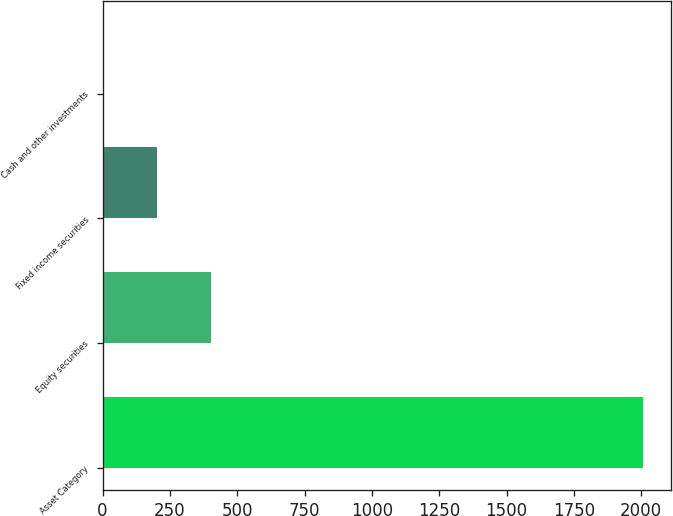Convert chart to OTSL. <chart><loc_0><loc_0><loc_500><loc_500><bar_chart><fcel>Asset Category<fcel>Equity securities<fcel>Fixed income securities<fcel>Cash and other investments<nl><fcel>2008<fcel>402.4<fcel>201.7<fcel>1<nl></chart> 